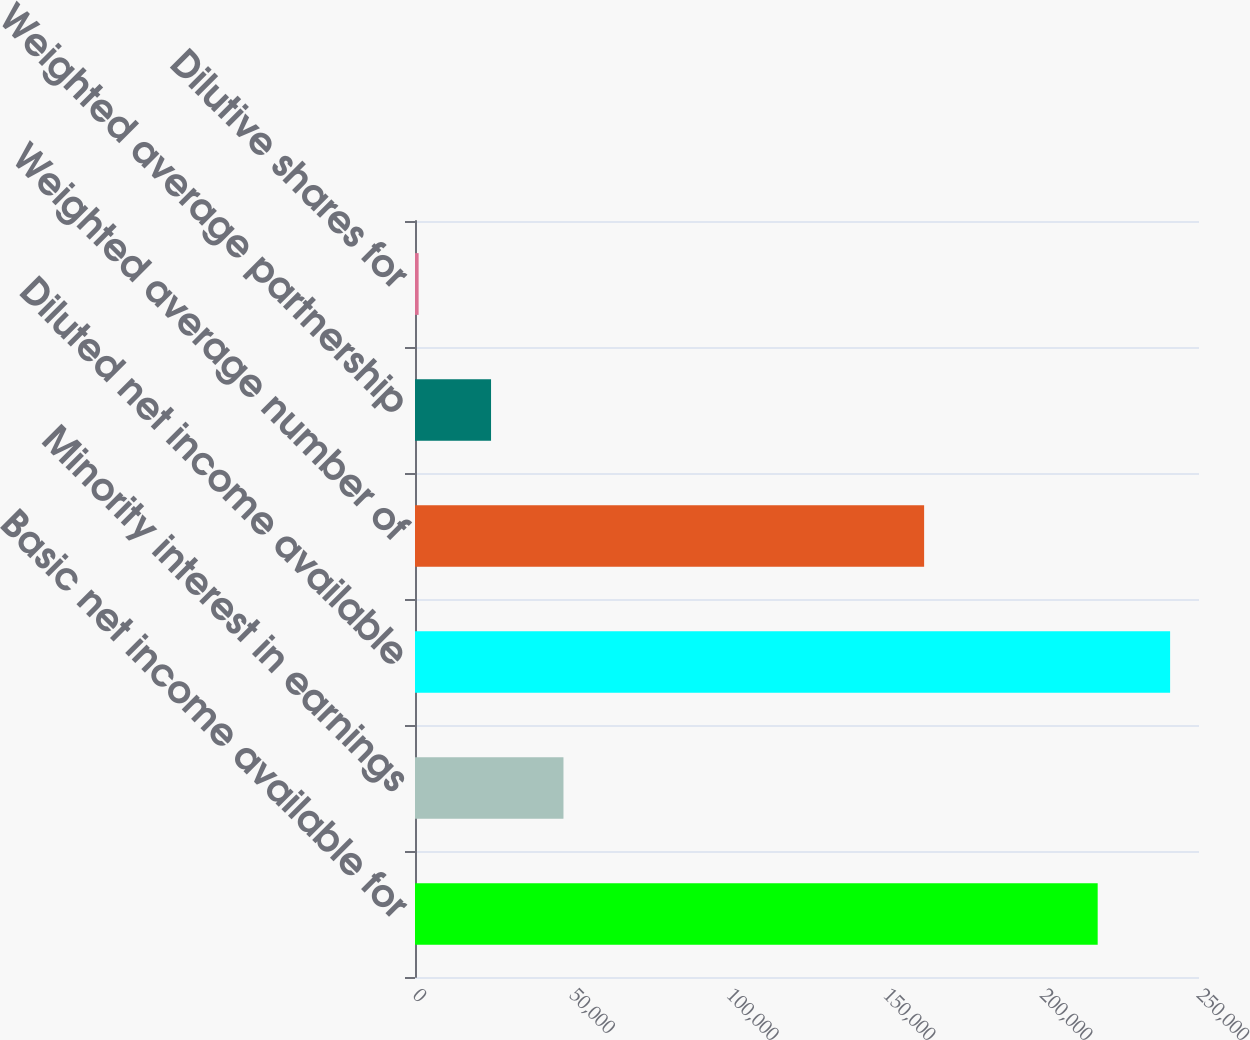Convert chart. <chart><loc_0><loc_0><loc_500><loc_500><bar_chart><fcel>Basic net income available for<fcel>Minority interest in earnings<fcel>Diluted net income available<fcel>Weighted average number of<fcel>Weighted average partnership<fcel>Dilutive shares for<nl><fcel>217692<fcel>47342.2<fcel>240786<fcel>162349<fcel>24248.6<fcel>1155<nl></chart> 